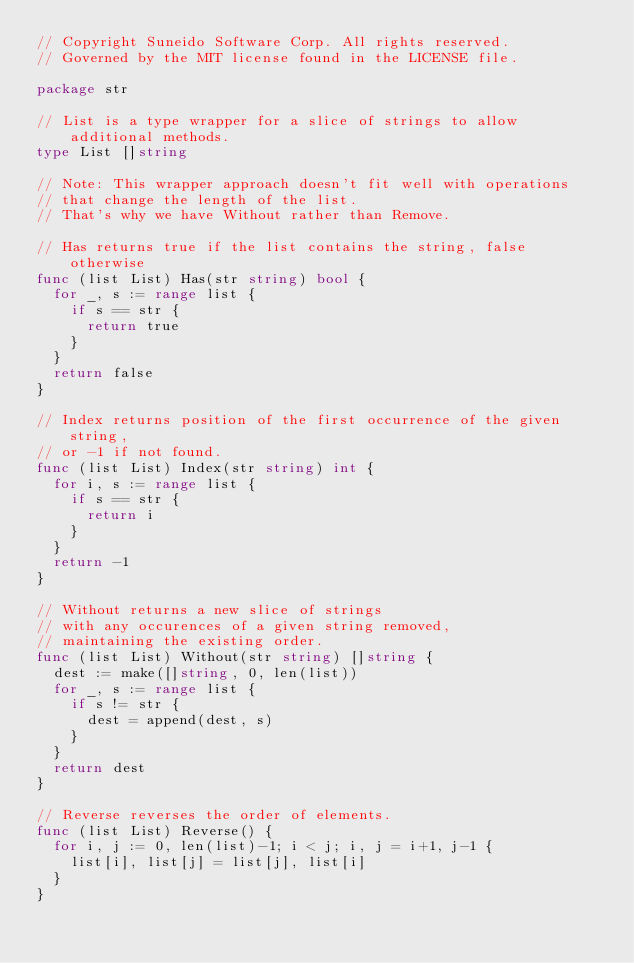Convert code to text. <code><loc_0><loc_0><loc_500><loc_500><_Go_>// Copyright Suneido Software Corp. All rights reserved.
// Governed by the MIT license found in the LICENSE file.

package str

// List is a type wrapper for a slice of strings to allow additional methods.
type List []string

// Note: This wrapper approach doesn't fit well with operations
// that change the length of the list.
// That's why we have Without rather than Remove.

// Has returns true if the list contains the string, false otherwise
func (list List) Has(str string) bool {
	for _, s := range list {
		if s == str {
			return true
		}
	}
	return false
}

// Index returns position of the first occurrence of the given string,
// or -1 if not found.
func (list List) Index(str string) int {
	for i, s := range list {
		if s == str {
			return i
		}
	}
	return -1
}

// Without returns a new slice of strings
// with any occurences of a given string removed,
// maintaining the existing order.
func (list List) Without(str string) []string {
	dest := make([]string, 0, len(list))
	for _, s := range list {
		if s != str {
			dest = append(dest, s)
		}
	}
	return dest
}

// Reverse reverses the order of elements.
func (list List) Reverse() {
	for i, j := 0, len(list)-1; i < j; i, j = i+1, j-1 {
		list[i], list[j] = list[j], list[i]
	}
}
</code> 